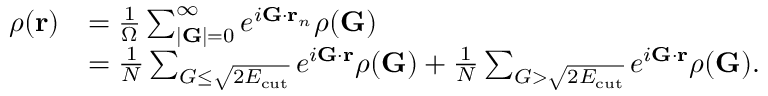Convert formula to latex. <formula><loc_0><loc_0><loc_500><loc_500>\begin{array} { r l } { \rho ( r ) } & { = \frac { 1 } { \Omega } \sum _ { | G | = 0 } ^ { \infty } e ^ { i G \cdot r _ { n } } \rho ( G ) } \\ & { = \frac { 1 } { N } \sum _ { G \leq \sqrt { 2 E _ { c u t } } } e ^ { i G \cdot r } \rho ( G ) + \frac { 1 } { N } \sum _ { G > \sqrt { 2 E _ { c u t } } } e ^ { i G \cdot r } \rho ( G ) . } \end{array}</formula> 